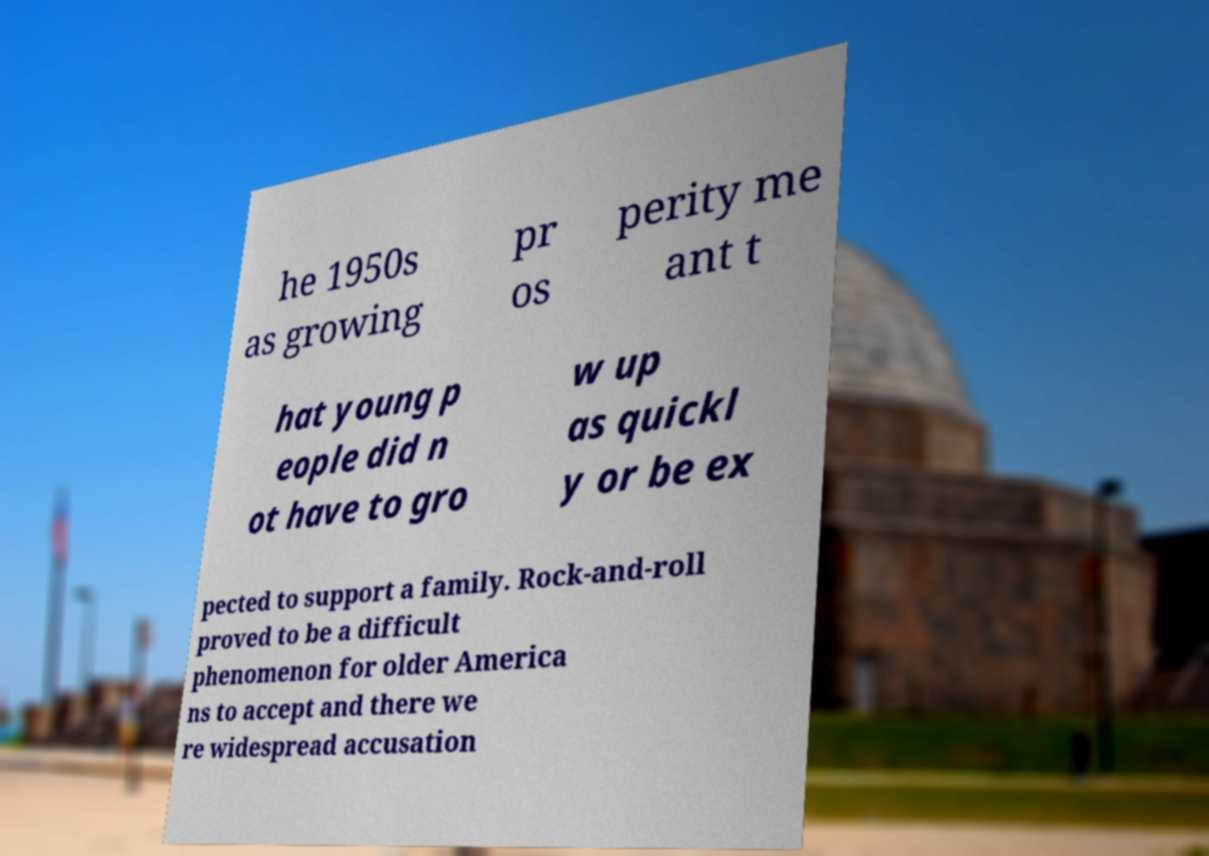What messages or text are displayed in this image? I need them in a readable, typed format. he 1950s as growing pr os perity me ant t hat young p eople did n ot have to gro w up as quickl y or be ex pected to support a family. Rock-and-roll proved to be a difficult phenomenon for older America ns to accept and there we re widespread accusation 